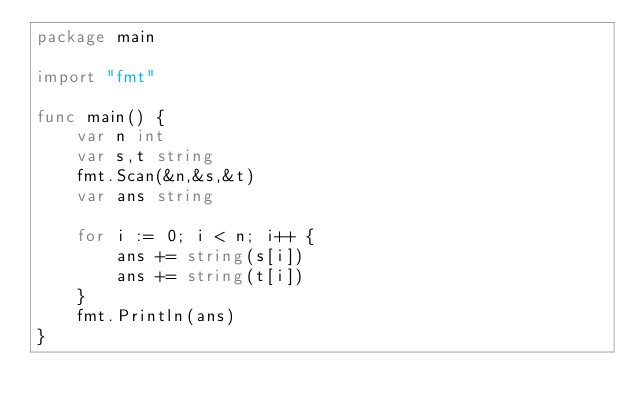Convert code to text. <code><loc_0><loc_0><loc_500><loc_500><_Go_>package main

import "fmt"

func main() {
	var n int
	var s,t string
	fmt.Scan(&n,&s,&t)
	var ans string

	for i := 0; i < n; i++ {
		ans += string(s[i])
		ans += string(t[i])
	}
	fmt.Println(ans)
}
</code> 